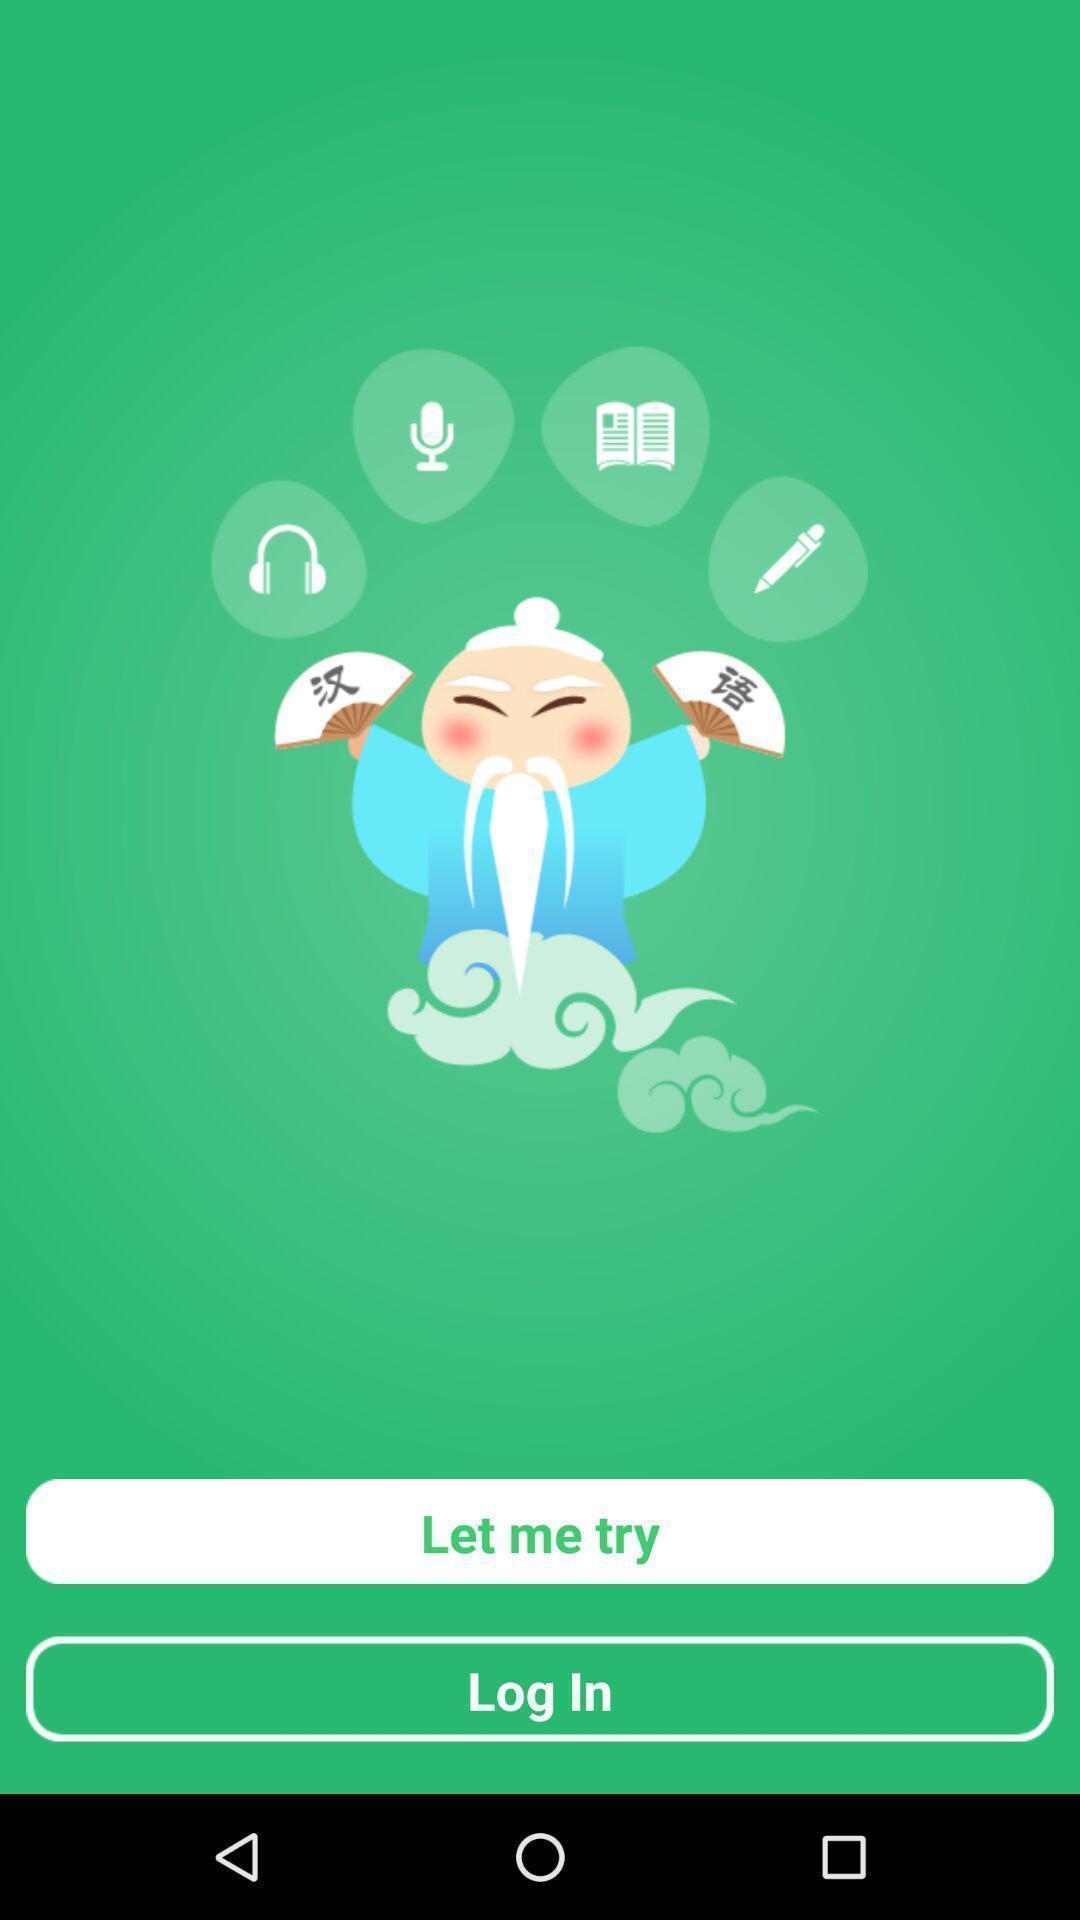Tell me about the visual elements in this screen capture. Welcome page. 